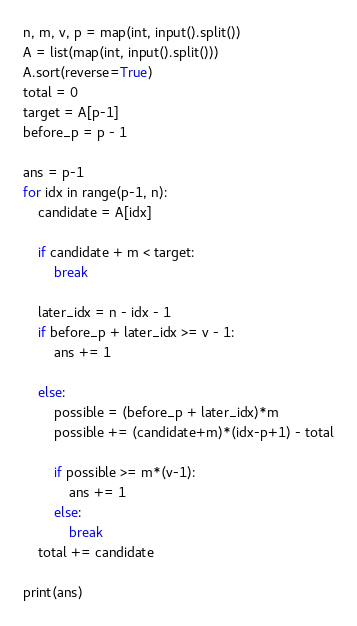Convert code to text. <code><loc_0><loc_0><loc_500><loc_500><_Python_>n, m, v, p = map(int, input().split())
A = list(map(int, input().split()))
A.sort(reverse=True)
total = 0
target = A[p-1]
before_p = p - 1

ans = p-1
for idx in range(p-1, n):
    candidate = A[idx]

    if candidate + m < target:
        break

    later_idx = n - idx - 1
    if before_p + later_idx >= v - 1:
        ans += 1

    else:
        possible = (before_p + later_idx)*m
        possible += (candidate+m)*(idx-p+1) - total

        if possible >= m*(v-1):
            ans += 1
        else:
            break
    total += candidate

print(ans)
</code> 